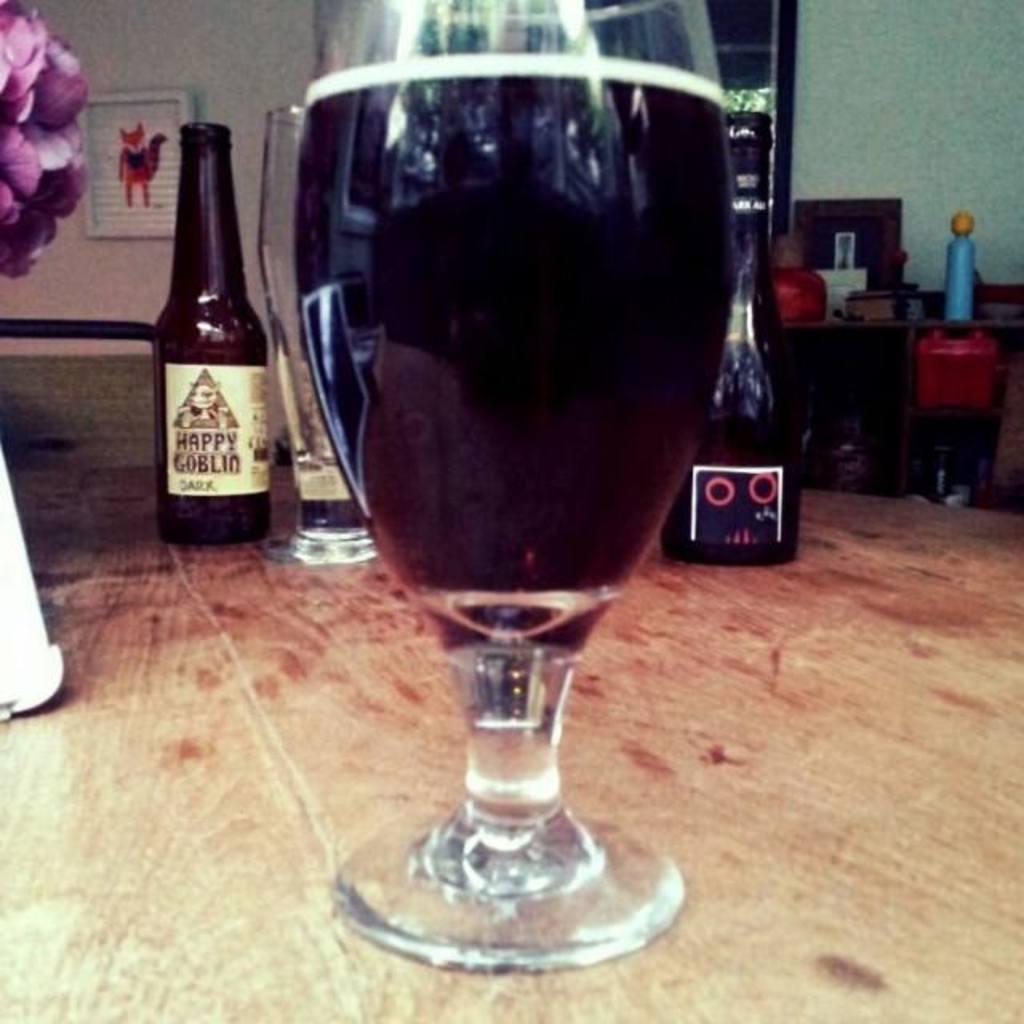How would you summarize this image in a sentence or two? This picture shows bottles and wine glass on the table 